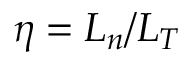<formula> <loc_0><loc_0><loc_500><loc_500>\eta = L _ { n } / L _ { T }</formula> 